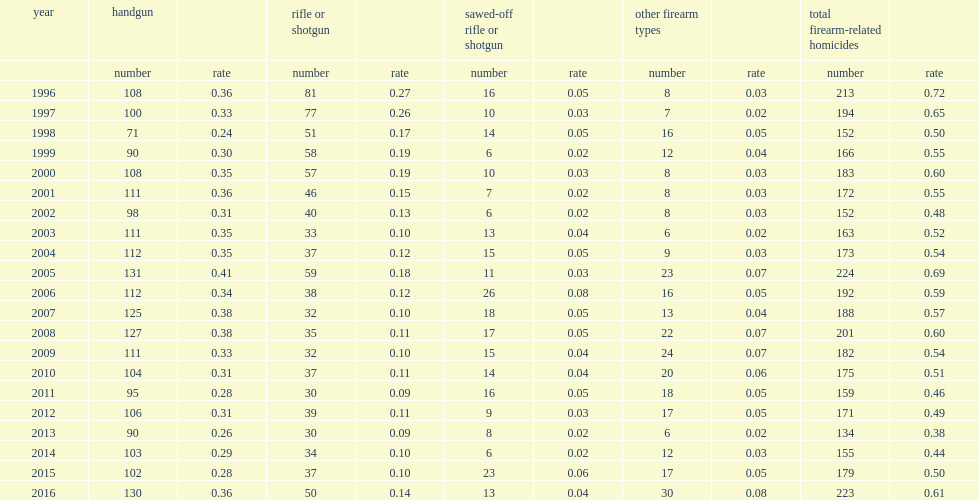What was the number of total firearm-related homicides in 2016? 223.0. What was the rate of firearm-related homicides in 2016? 0.61. What was the percentage of handgun representing all firearm-related homicides in 2016? 0.58296. Which year reported the highest rate for handgun since 2008? 2016.0. What was the change in number of homicides involving a rifle or a shotgun from 2015 to 2016? 13. What was the percentage of homicides involving a rifle or a shotgun representing all firearm-related homicides in 2016? 0.224215. 